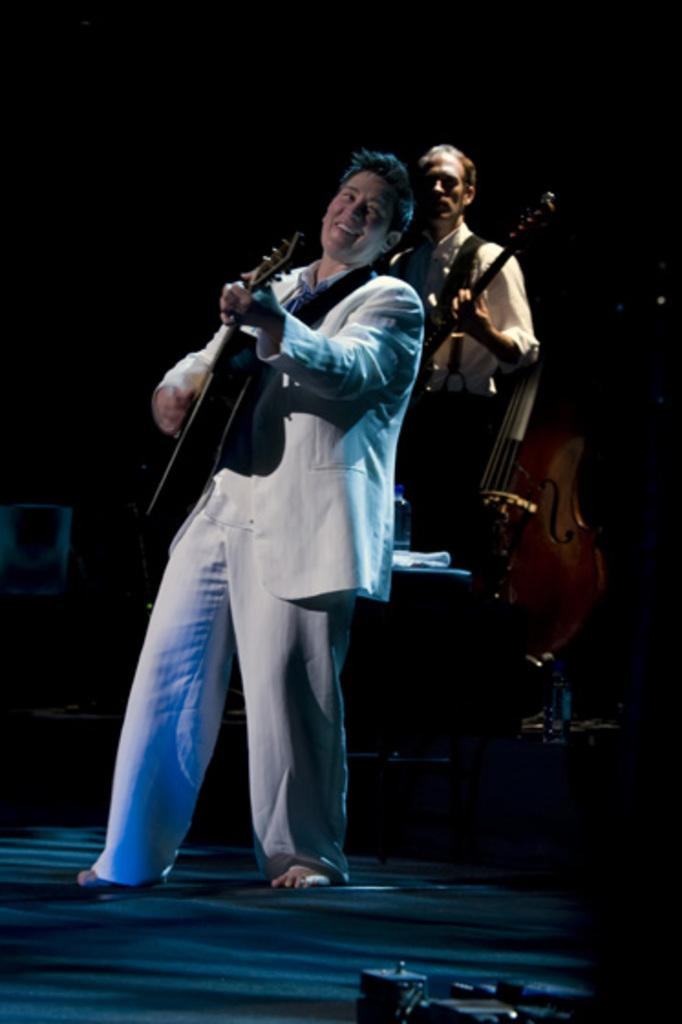How many people are in the image? There are two persons in the image. What are the persons doing in the image? Both persons are playing musical instruments. What type of jar can be seen filled with jelly in the image? There is no jar or jelly present in the image; the image only features two persons playing musical instruments. 